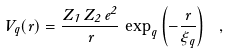Convert formula to latex. <formula><loc_0><loc_0><loc_500><loc_500>V _ { q } ( r ) = \frac { Z _ { 1 } \, Z _ { 2 } \, e ^ { 2 } } { r } \, \exp _ { q } \left ( - \frac { r } { \xi _ { q } } \right ) \ ,</formula> 